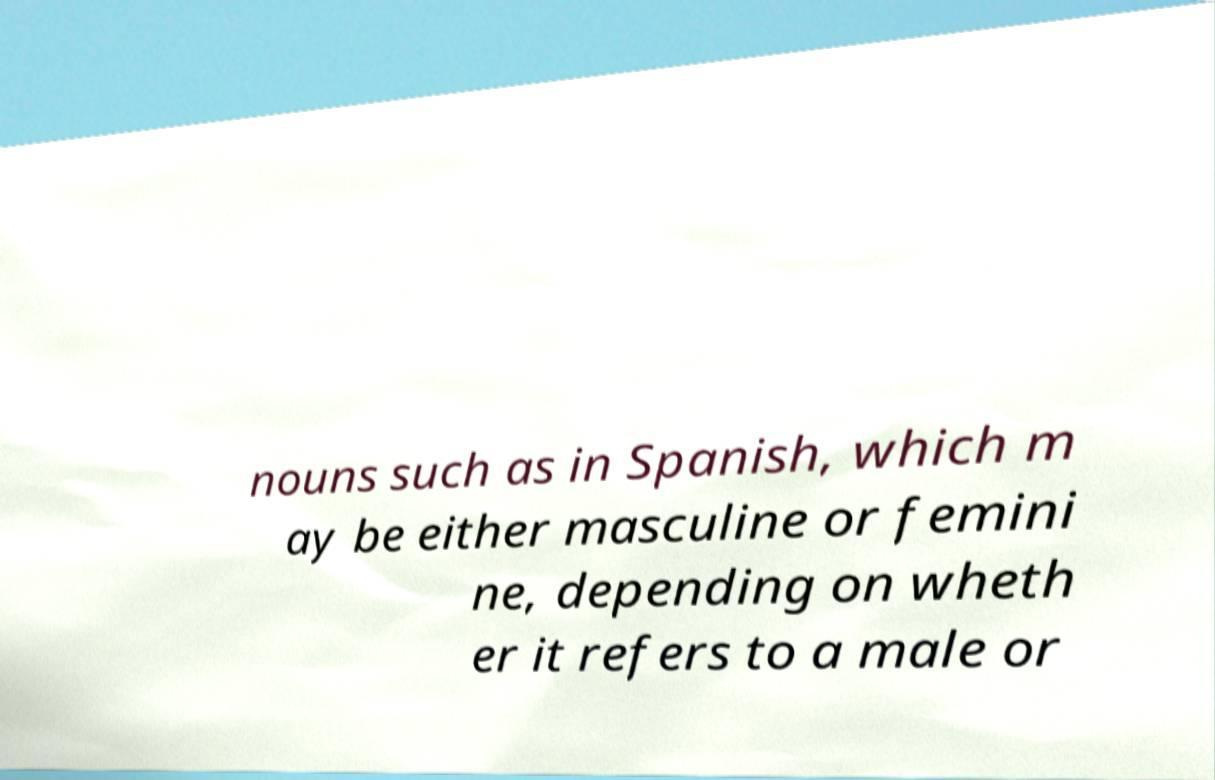Could you extract and type out the text from this image? nouns such as in Spanish, which m ay be either masculine or femini ne, depending on wheth er it refers to a male or 